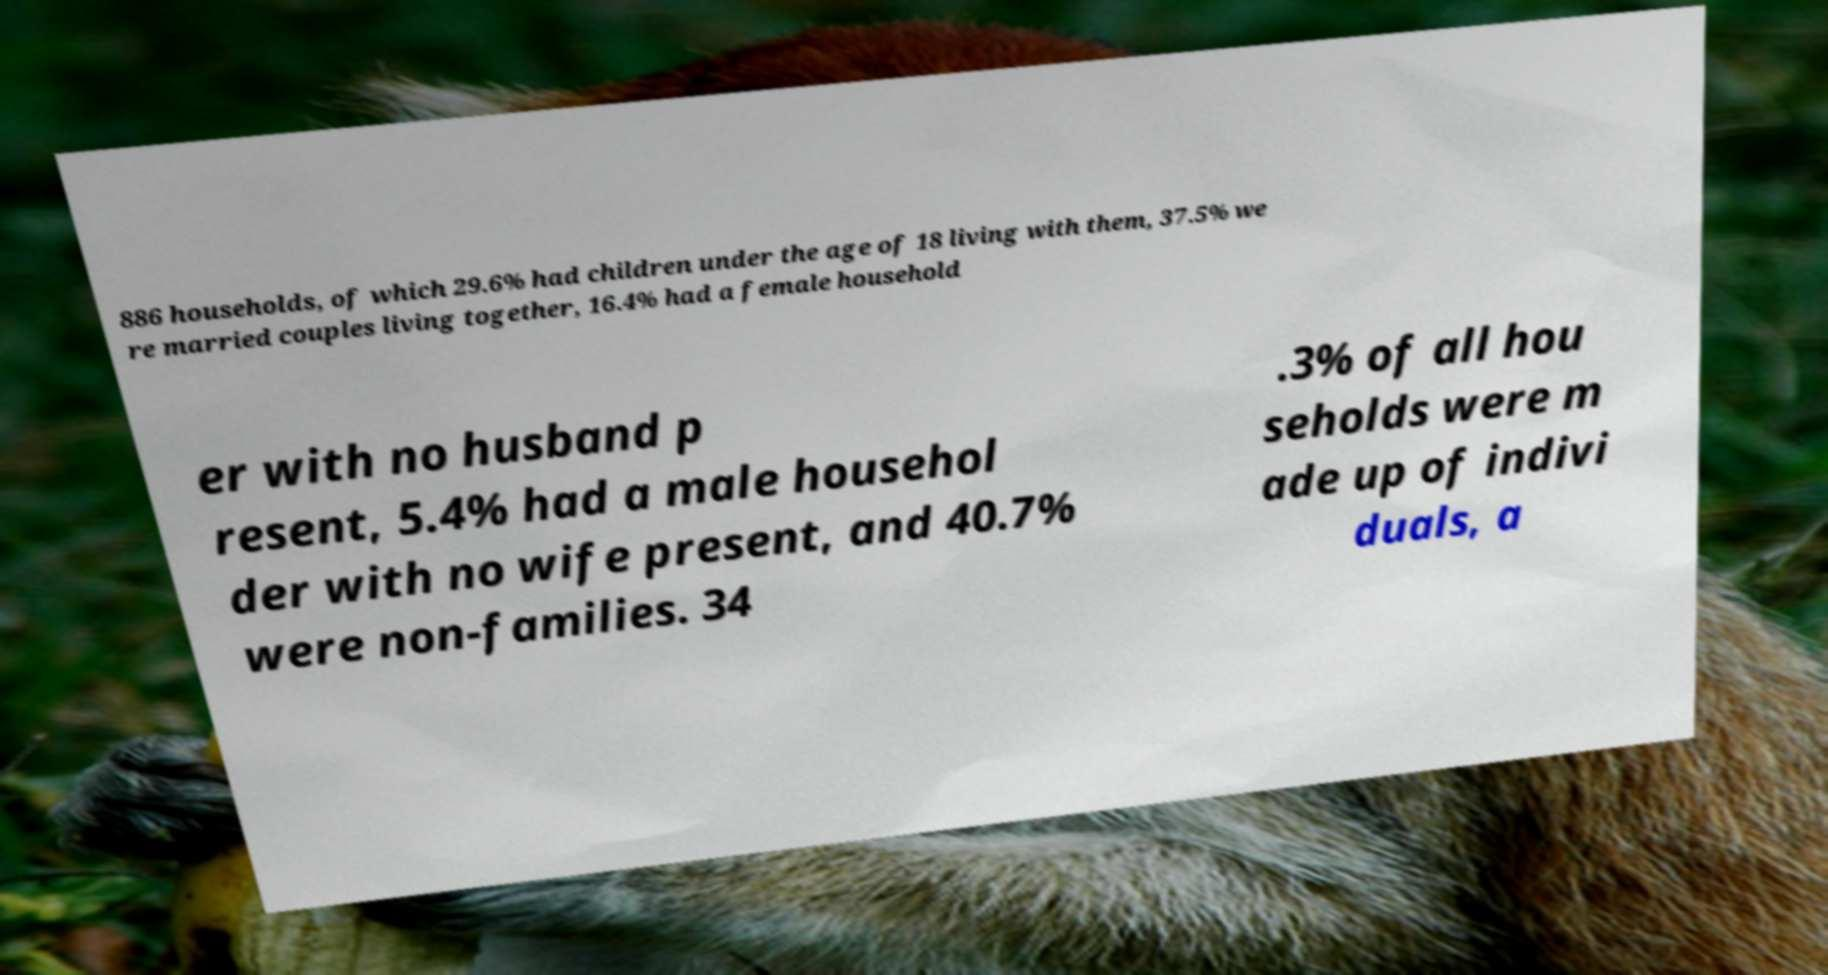Can you read and provide the text displayed in the image?This photo seems to have some interesting text. Can you extract and type it out for me? 886 households, of which 29.6% had children under the age of 18 living with them, 37.5% we re married couples living together, 16.4% had a female household er with no husband p resent, 5.4% had a male househol der with no wife present, and 40.7% were non-families. 34 .3% of all hou seholds were m ade up of indivi duals, a 